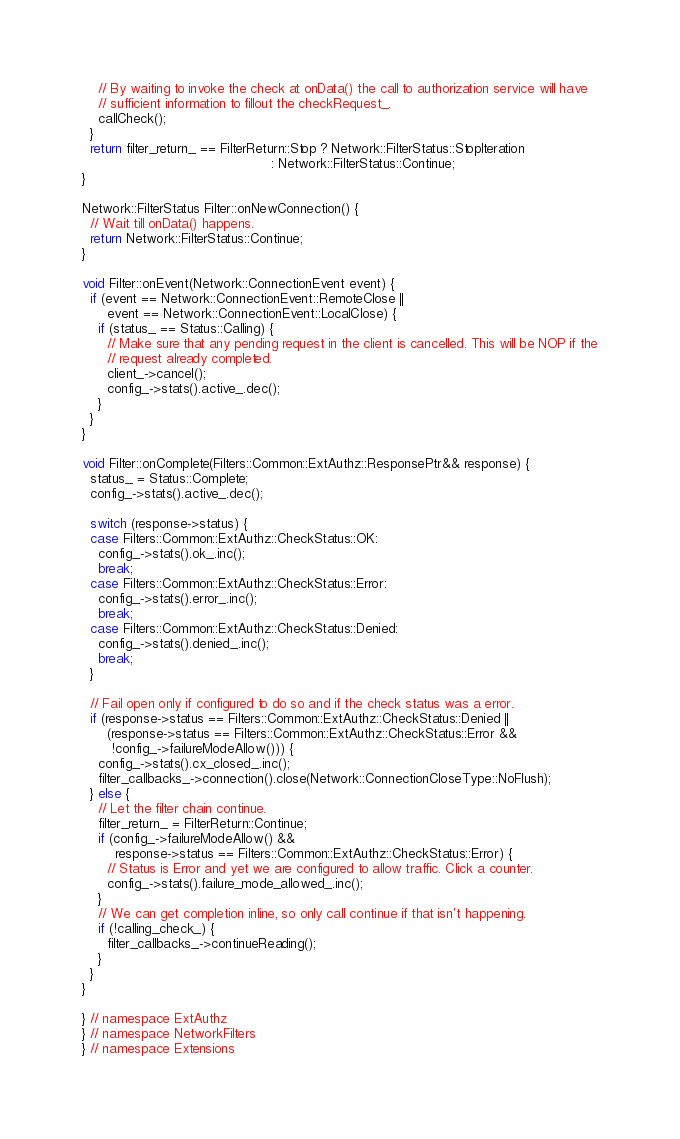<code> <loc_0><loc_0><loc_500><loc_500><_C++_>    // By waiting to invoke the check at onData() the call to authorization service will have
    // sufficient information to fillout the checkRequest_.
    callCheck();
  }
  return filter_return_ == FilterReturn::Stop ? Network::FilterStatus::StopIteration
                                              : Network::FilterStatus::Continue;
}

Network::FilterStatus Filter::onNewConnection() {
  // Wait till onData() happens.
  return Network::FilterStatus::Continue;
}

void Filter::onEvent(Network::ConnectionEvent event) {
  if (event == Network::ConnectionEvent::RemoteClose ||
      event == Network::ConnectionEvent::LocalClose) {
    if (status_ == Status::Calling) {
      // Make sure that any pending request in the client is cancelled. This will be NOP if the
      // request already completed.
      client_->cancel();
      config_->stats().active_.dec();
    }
  }
}

void Filter::onComplete(Filters::Common::ExtAuthz::ResponsePtr&& response) {
  status_ = Status::Complete;
  config_->stats().active_.dec();

  switch (response->status) {
  case Filters::Common::ExtAuthz::CheckStatus::OK:
    config_->stats().ok_.inc();
    break;
  case Filters::Common::ExtAuthz::CheckStatus::Error:
    config_->stats().error_.inc();
    break;
  case Filters::Common::ExtAuthz::CheckStatus::Denied:
    config_->stats().denied_.inc();
    break;
  }

  // Fail open only if configured to do so and if the check status was a error.
  if (response->status == Filters::Common::ExtAuthz::CheckStatus::Denied ||
      (response->status == Filters::Common::ExtAuthz::CheckStatus::Error &&
       !config_->failureModeAllow())) {
    config_->stats().cx_closed_.inc();
    filter_callbacks_->connection().close(Network::ConnectionCloseType::NoFlush);
  } else {
    // Let the filter chain continue.
    filter_return_ = FilterReturn::Continue;
    if (config_->failureModeAllow() &&
        response->status == Filters::Common::ExtAuthz::CheckStatus::Error) {
      // Status is Error and yet we are configured to allow traffic. Click a counter.
      config_->stats().failure_mode_allowed_.inc();
    }
    // We can get completion inline, so only call continue if that isn't happening.
    if (!calling_check_) {
      filter_callbacks_->continueReading();
    }
  }
}

} // namespace ExtAuthz
} // namespace NetworkFilters
} // namespace Extensions</code> 